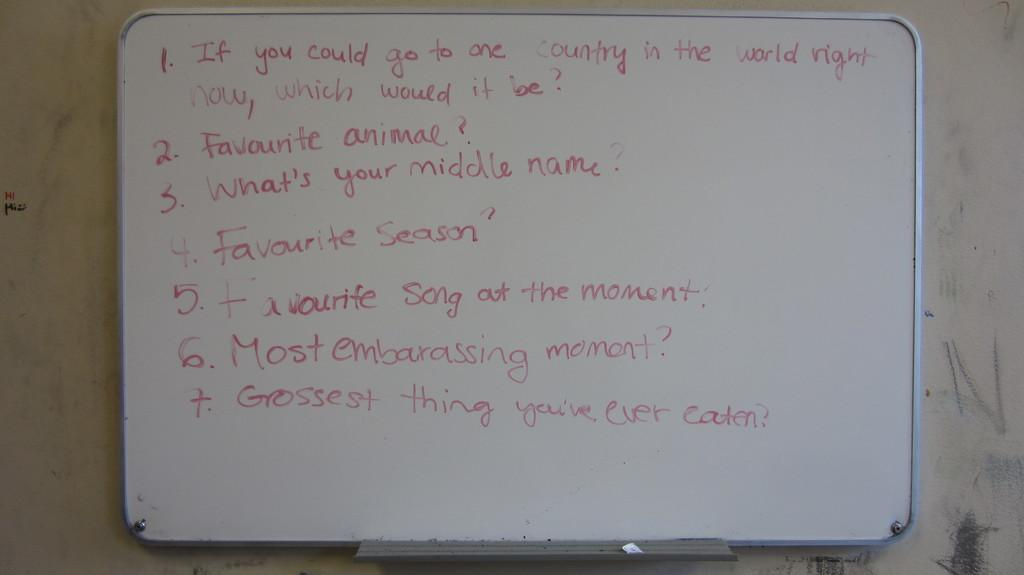What is the primary object in the image? There is a white color board in the image. What can be seen written on the board? Something is written on the board in red color. How many rings are visible on the color board in the image? There are no rings visible on the color board in the image. What type of pies are being served on the color board in the image? There are no pies present on the color board in the image. 